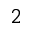Convert formula to latex. <formula><loc_0><loc_0><loc_500><loc_500>^ { 2 }</formula> 